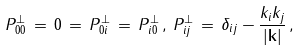Convert formula to latex. <formula><loc_0><loc_0><loc_500><loc_500>P ^ { \perp } _ { 0 0 } \, = \, 0 \, = \, P ^ { \perp } _ { 0 i } \, = \, P ^ { \perp } _ { i 0 } \, , \, P _ { i j } ^ { \perp } \, = \, \delta _ { i j } - \frac { k _ { i } k _ { j } } { | { \mathbf k } | } \, ,</formula> 